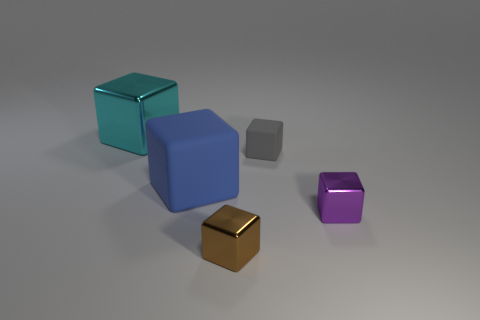Can you tell which cube is closest to the camera? The teal-colored cube seems closest to the camera, positioned clearly in front of the others. How can you discern its position relative to the others? Position and perspective in the image reveal that the teal cube is larger and fully detailed compared to the other cubes, and overlaps parts of the blue cube, indicating its closeness to the viewer. 